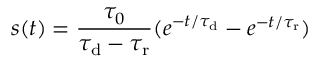<formula> <loc_0><loc_0><loc_500><loc_500>s ( t ) = \frac { \tau _ { 0 } } { \tau _ { \mathrm d } - \tau _ { \mathrm r } } ( e ^ { - t / \tau _ { \mathrm d } } - e ^ { - t / \tau _ { \mathrm r } } )</formula> 